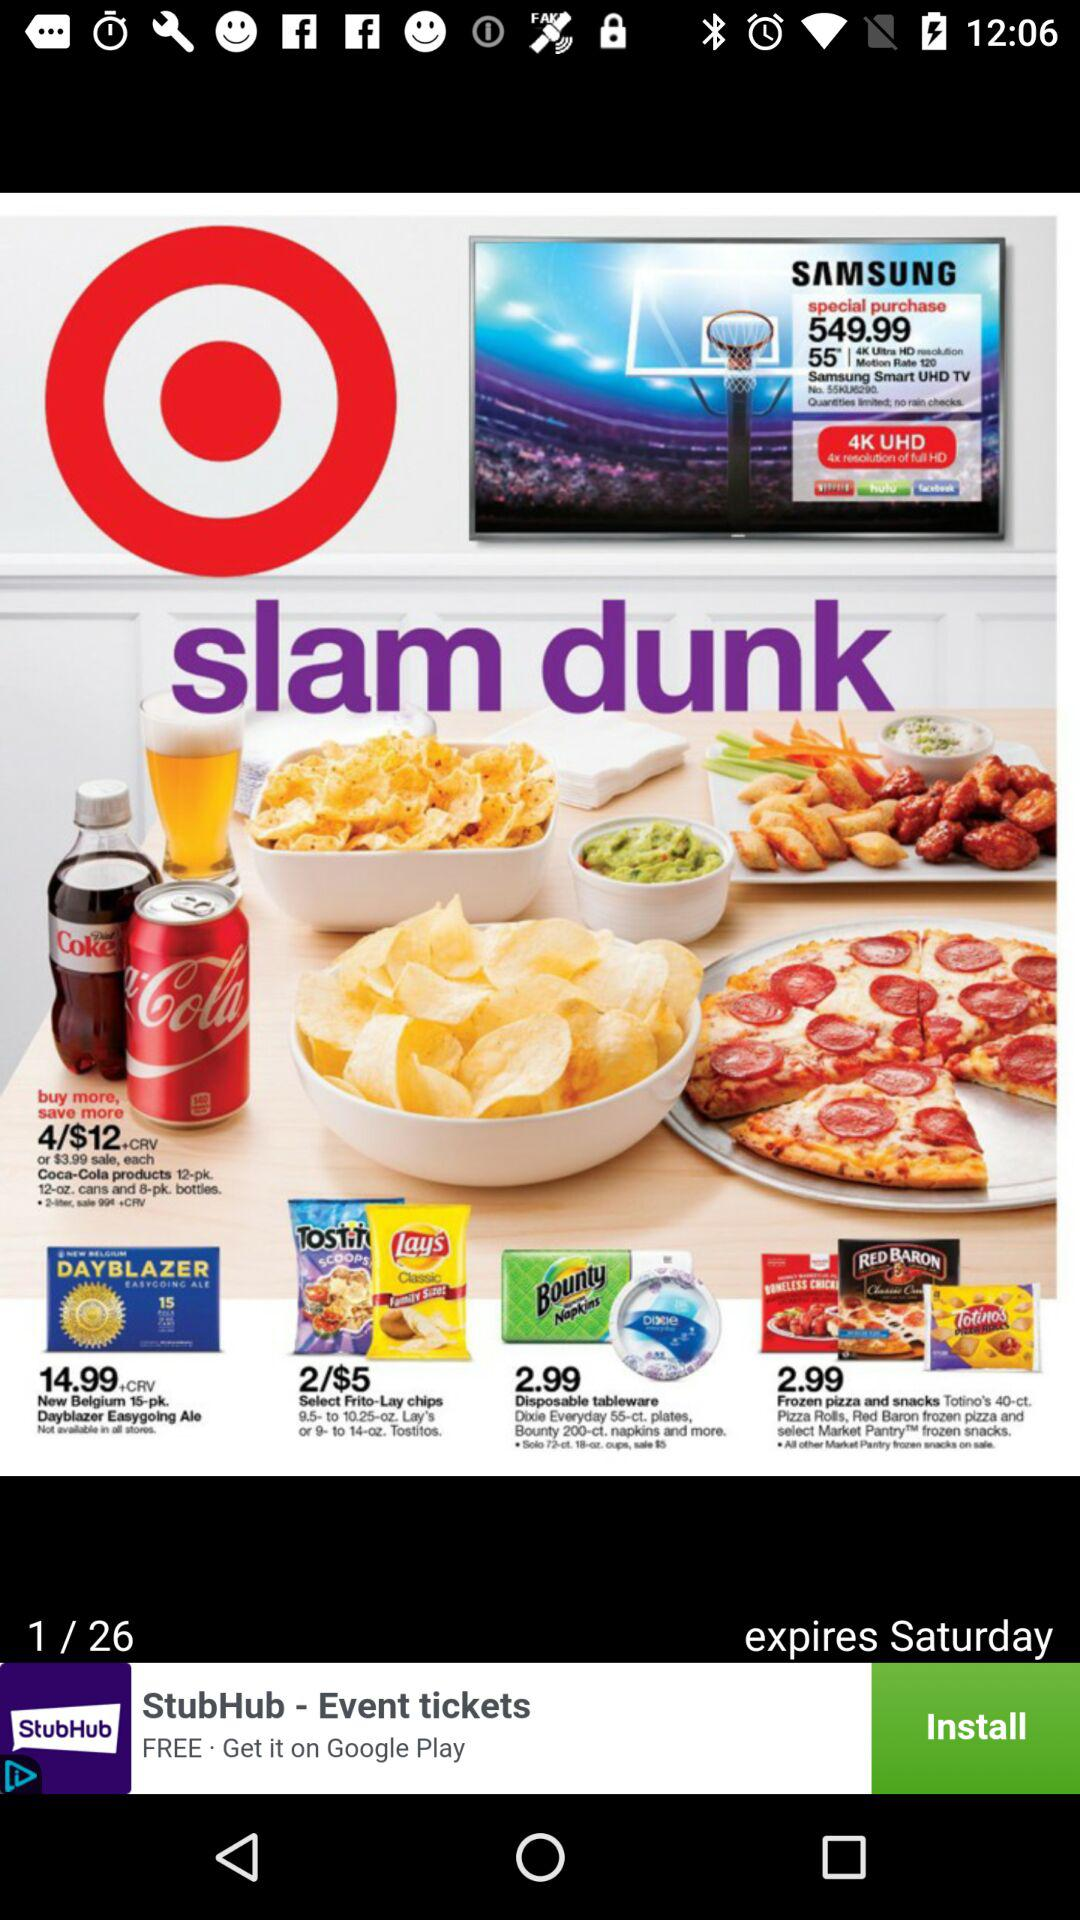What is the expiration day? The day is Saturday. 